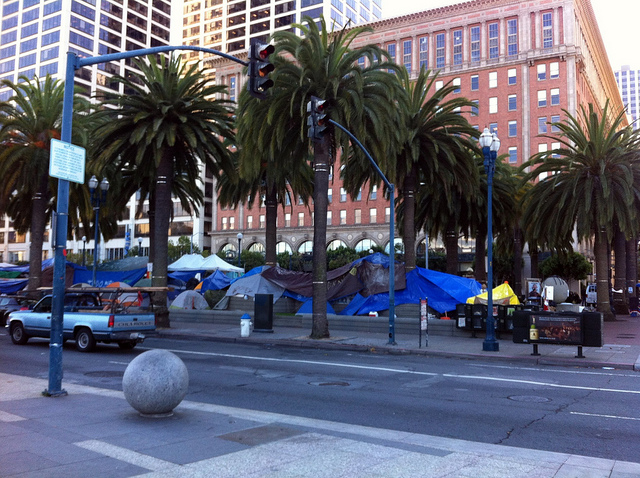<image>Is this a tropical scene? I am not sure if this is a tropical scene. It can be either 'yes' or 'no'. Is this a tropical scene? I don't know if this is a tropical scene. It can be both tropical or not tropical. 